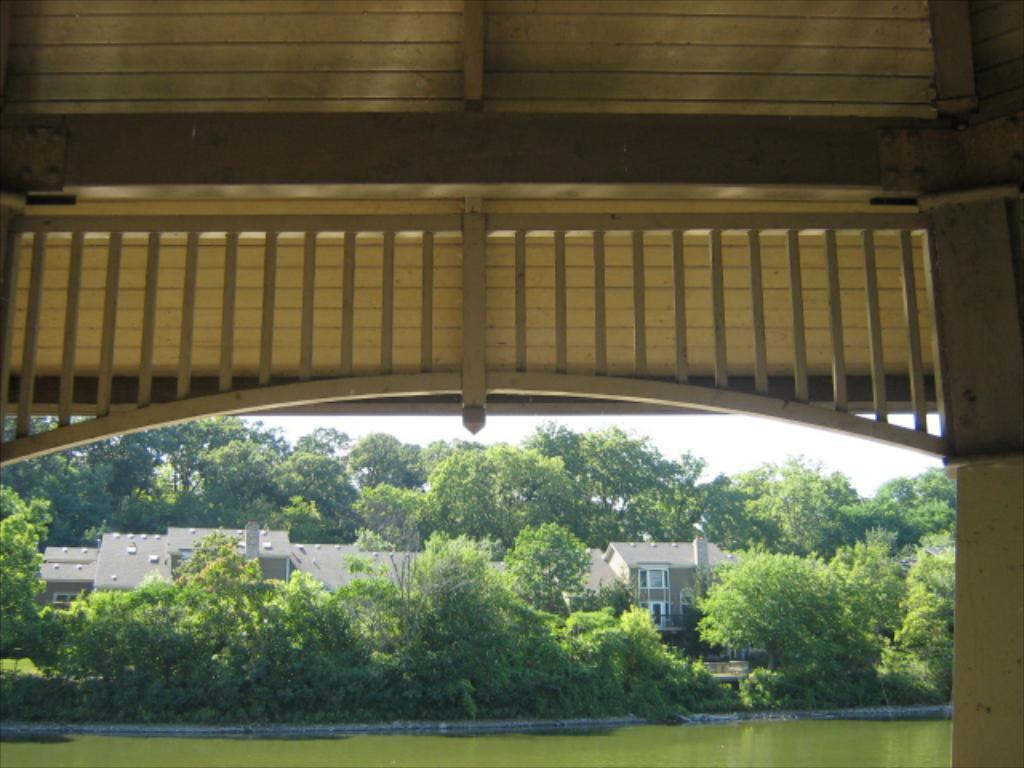What type of structure is present in the image? There is a building in the image. What feature can be seen on the building? The building has windows. What natural elements are visible in the image? There are many trees and a body of water in the image. What type of barrier is present in the image? There is a wooden fence in the image. What part of the natural environment is visible in the image? The sky is visible in the image. What type of bread can be seen in the stocking hanging from the building? There is no bread or stocking present in the image; it only features a building, trees, a body of water, a wooden fence, and the sky. 